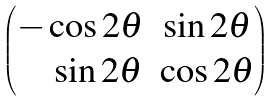<formula> <loc_0><loc_0><loc_500><loc_500>\begin{pmatrix} - \cos 2 \theta & \sin 2 \theta \\ \quad \sin 2 \theta & \cos 2 \theta \end{pmatrix}</formula> 